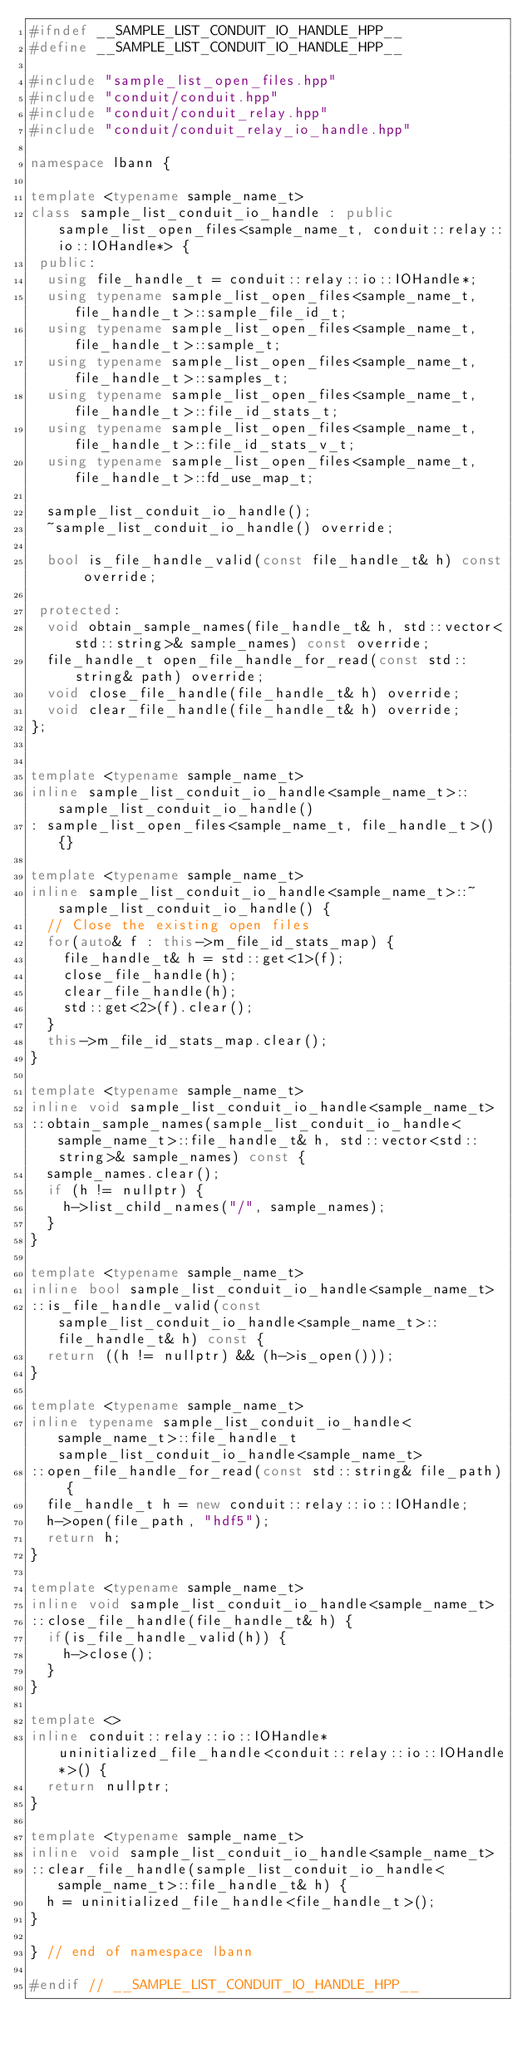<code> <loc_0><loc_0><loc_500><loc_500><_C++_>#ifndef __SAMPLE_LIST_CONDUIT_IO_HANDLE_HPP__
#define __SAMPLE_LIST_CONDUIT_IO_HANDLE_HPP__

#include "sample_list_open_files.hpp"
#include "conduit/conduit.hpp"
#include "conduit/conduit_relay.hpp"
#include "conduit/conduit_relay_io_handle.hpp"

namespace lbann {

template <typename sample_name_t>
class sample_list_conduit_io_handle : public sample_list_open_files<sample_name_t, conduit::relay::io::IOHandle*> {
 public:
  using file_handle_t = conduit::relay::io::IOHandle*;
  using typename sample_list_open_files<sample_name_t, file_handle_t>::sample_file_id_t;
  using typename sample_list_open_files<sample_name_t, file_handle_t>::sample_t;
  using typename sample_list_open_files<sample_name_t, file_handle_t>::samples_t;
  using typename sample_list_open_files<sample_name_t, file_handle_t>::file_id_stats_t;
  using typename sample_list_open_files<sample_name_t, file_handle_t>::file_id_stats_v_t;
  using typename sample_list_open_files<sample_name_t, file_handle_t>::fd_use_map_t;

  sample_list_conduit_io_handle();
  ~sample_list_conduit_io_handle() override;

  bool is_file_handle_valid(const file_handle_t& h) const override;

 protected:
  void obtain_sample_names(file_handle_t& h, std::vector<std::string>& sample_names) const override;
  file_handle_t open_file_handle_for_read(const std::string& path) override;
  void close_file_handle(file_handle_t& h) override;
  void clear_file_handle(file_handle_t& h) override;
};


template <typename sample_name_t>
inline sample_list_conduit_io_handle<sample_name_t>::sample_list_conduit_io_handle()
: sample_list_open_files<sample_name_t, file_handle_t>() {}

template <typename sample_name_t>
inline sample_list_conduit_io_handle<sample_name_t>::~sample_list_conduit_io_handle() {
  // Close the existing open files
  for(auto& f : this->m_file_id_stats_map) {
    file_handle_t& h = std::get<1>(f);
    close_file_handle(h);
    clear_file_handle(h);
    std::get<2>(f).clear();
  }
  this->m_file_id_stats_map.clear();
}

template <typename sample_name_t>
inline void sample_list_conduit_io_handle<sample_name_t>
::obtain_sample_names(sample_list_conduit_io_handle<sample_name_t>::file_handle_t& h, std::vector<std::string>& sample_names) const {
  sample_names.clear();
  if (h != nullptr) {
    h->list_child_names("/", sample_names);
  }
}

template <typename sample_name_t>
inline bool sample_list_conduit_io_handle<sample_name_t>
::is_file_handle_valid(const sample_list_conduit_io_handle<sample_name_t>::file_handle_t& h) const {
  return ((h != nullptr) && (h->is_open()));
}

template <typename sample_name_t>
inline typename sample_list_conduit_io_handle<sample_name_t>::file_handle_t sample_list_conduit_io_handle<sample_name_t>
::open_file_handle_for_read(const std::string& file_path) {
  file_handle_t h = new conduit::relay::io::IOHandle;
  h->open(file_path, "hdf5");
  return h;
}

template <typename sample_name_t>
inline void sample_list_conduit_io_handle<sample_name_t>
::close_file_handle(file_handle_t& h) {
  if(is_file_handle_valid(h)) {
    h->close();
  }
}

template <>
inline conduit::relay::io::IOHandle* uninitialized_file_handle<conduit::relay::io::IOHandle*>() {
  return nullptr;
}

template <typename sample_name_t>
inline void sample_list_conduit_io_handle<sample_name_t>
::clear_file_handle(sample_list_conduit_io_handle<sample_name_t>::file_handle_t& h) {
  h = uninitialized_file_handle<file_handle_t>();
}

} // end of namespace lbann

#endif // __SAMPLE_LIST_CONDUIT_IO_HANDLE_HPP__
</code> 